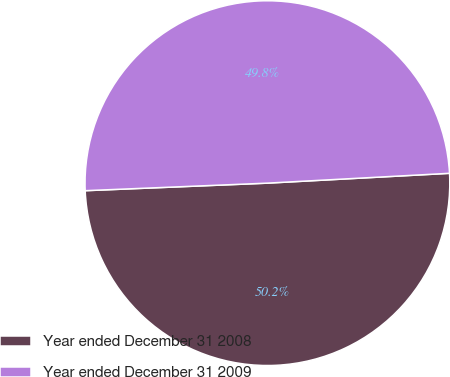<chart> <loc_0><loc_0><loc_500><loc_500><pie_chart><fcel>Year ended December 31 2008<fcel>Year ended December 31 2009<nl><fcel>50.2%<fcel>49.8%<nl></chart> 